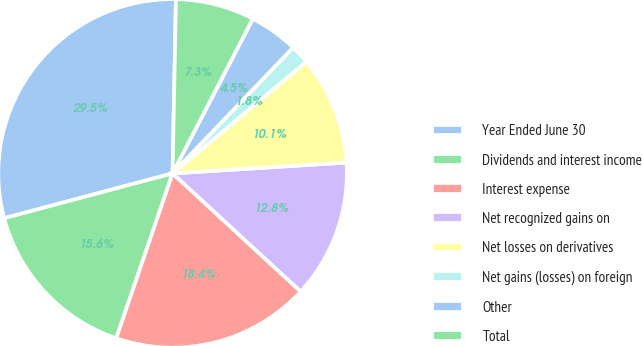Convert chart to OTSL. <chart><loc_0><loc_0><loc_500><loc_500><pie_chart><fcel>Year Ended June 30<fcel>Dividends and interest income<fcel>Interest expense<fcel>Net recognized gains on<fcel>Net losses on derivatives<fcel>Net gains (losses) on foreign<fcel>Other<fcel>Total<nl><fcel>29.46%<fcel>15.62%<fcel>18.39%<fcel>12.85%<fcel>10.08%<fcel>1.77%<fcel>4.54%<fcel>7.31%<nl></chart> 